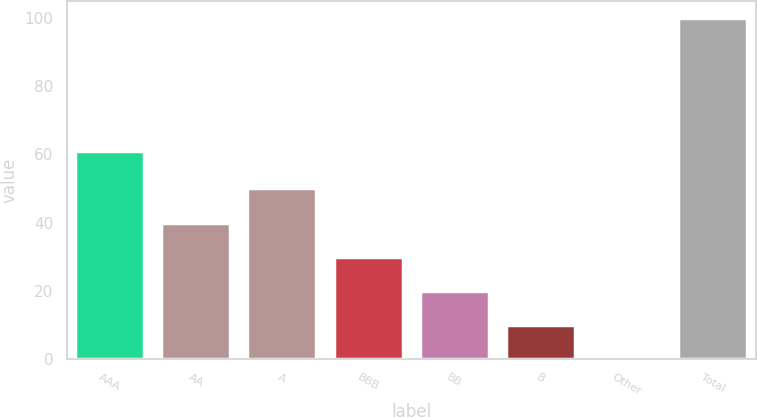Convert chart. <chart><loc_0><loc_0><loc_500><loc_500><bar_chart><fcel>AAA<fcel>AA<fcel>A<fcel>BBB<fcel>BB<fcel>B<fcel>Other<fcel>Total<nl><fcel>61.1<fcel>40.06<fcel>50.05<fcel>30.07<fcel>20.08<fcel>10.09<fcel>0.1<fcel>100<nl></chart> 